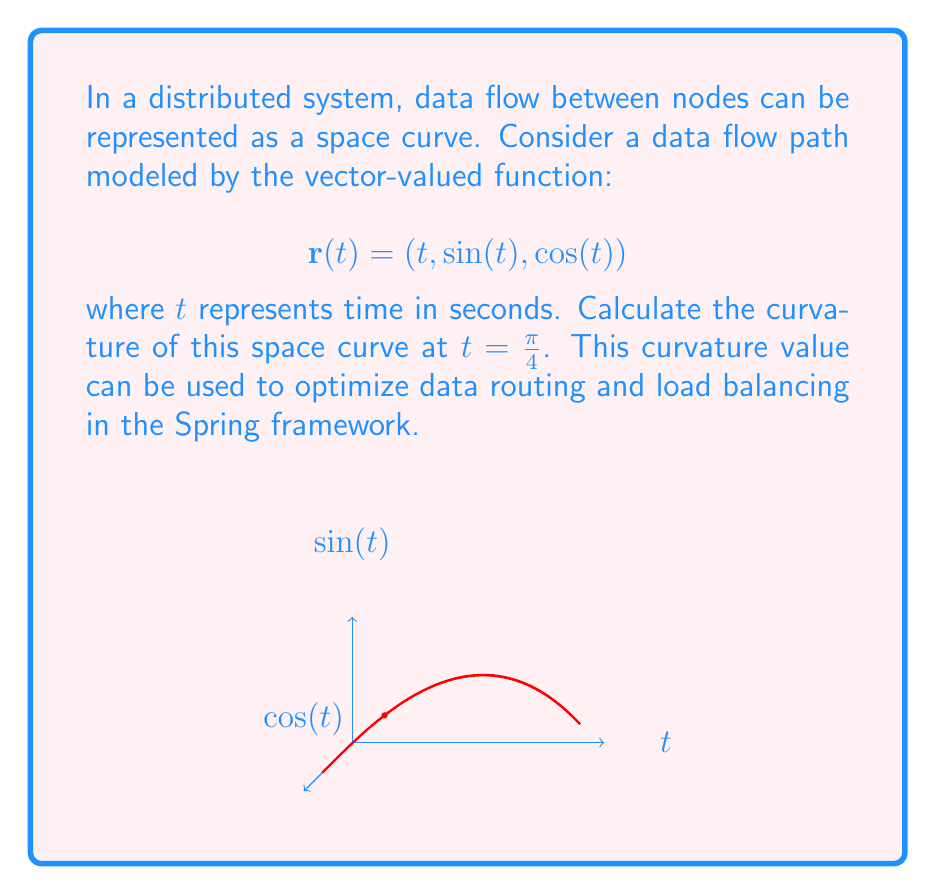Can you answer this question? To calculate the curvature of a space curve, we'll follow these steps:

1) The curvature $\kappa$ is given by the formula:

   $$\kappa = \frac{|\mathbf{r}'(t) \times \mathbf{r}''(t)|}{|\mathbf{r}'(t)|^3}$$

2) First, let's calculate $\mathbf{r}'(t)$:
   $$\mathbf{r}'(t) = (1, \cos(t), -\sin(t))$$

3) Now, let's calculate $\mathbf{r}''(t)$:
   $$\mathbf{r}''(t) = (0, -\sin(t), -\cos(t))$$

4) At $t = \frac{\pi}{4}$, we have:
   $$\mathbf{r}'(\frac{\pi}{4}) = (1, \frac{\sqrt{2}}{2}, -\frac{\sqrt{2}}{2})$$
   $$\mathbf{r}''(\frac{\pi}{4}) = (0, -\frac{\sqrt{2}}{2}, -\frac{\sqrt{2}}{2})$$

5) Now, let's calculate the cross product $\mathbf{r}'(\frac{\pi}{4}) \times \mathbf{r}''(\frac{\pi}{4})$:
   $$\mathbf{r}'(\frac{\pi}{4}) \times \mathbf{r}''(\frac{\pi}{4}) = \begin{vmatrix} 
   \mathbf{i} & \mathbf{j} & \mathbf{k} \\
   1 & \frac{\sqrt{2}}{2} & -\frac{\sqrt{2}}{2} \\
   0 & -\frac{\sqrt{2}}{2} & -\frac{\sqrt{2}}{2}
   \end{vmatrix} = (-\frac{1}{2}, \frac{\sqrt{2}}{2}, \frac{\sqrt{2}}{2})$$

6) The magnitude of this cross product is:
   $$|\mathbf{r}'(\frac{\pi}{4}) \times \mathbf{r}''(\frac{\pi}{4})| = \sqrt{(-\frac{1}{2})^2 + (\frac{\sqrt{2}}{2})^2 + (\frac{\sqrt{2}}{2})^2} = 1$$

7) The magnitude of $\mathbf{r}'(\frac{\pi}{4})$ is:
   $$|\mathbf{r}'(\frac{\pi}{4})| = \sqrt{1^2 + (\frac{\sqrt{2}}{2})^2 + (-\frac{\sqrt{2}}{2})^2} = \sqrt{2}$$

8) Now we can calculate the curvature:
   $$\kappa = \frac{|\mathbf{r}'(\frac{\pi}{4}) \times \mathbf{r}''(\frac{\pi}{4})|}{|\mathbf{r}'(\frac{\pi}{4})|^3} = \frac{1}{(\sqrt{2})^3} = \frac{1}{2\sqrt{2}}$$
Answer: $\frac{1}{2\sqrt{2}}$ 